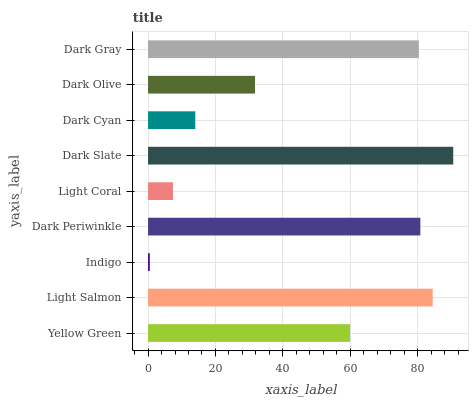Is Indigo the minimum?
Answer yes or no. Yes. Is Dark Slate the maximum?
Answer yes or no. Yes. Is Light Salmon the minimum?
Answer yes or no. No. Is Light Salmon the maximum?
Answer yes or no. No. Is Light Salmon greater than Yellow Green?
Answer yes or no. Yes. Is Yellow Green less than Light Salmon?
Answer yes or no. Yes. Is Yellow Green greater than Light Salmon?
Answer yes or no. No. Is Light Salmon less than Yellow Green?
Answer yes or no. No. Is Yellow Green the high median?
Answer yes or no. Yes. Is Yellow Green the low median?
Answer yes or no. Yes. Is Indigo the high median?
Answer yes or no. No. Is Light Coral the low median?
Answer yes or no. No. 